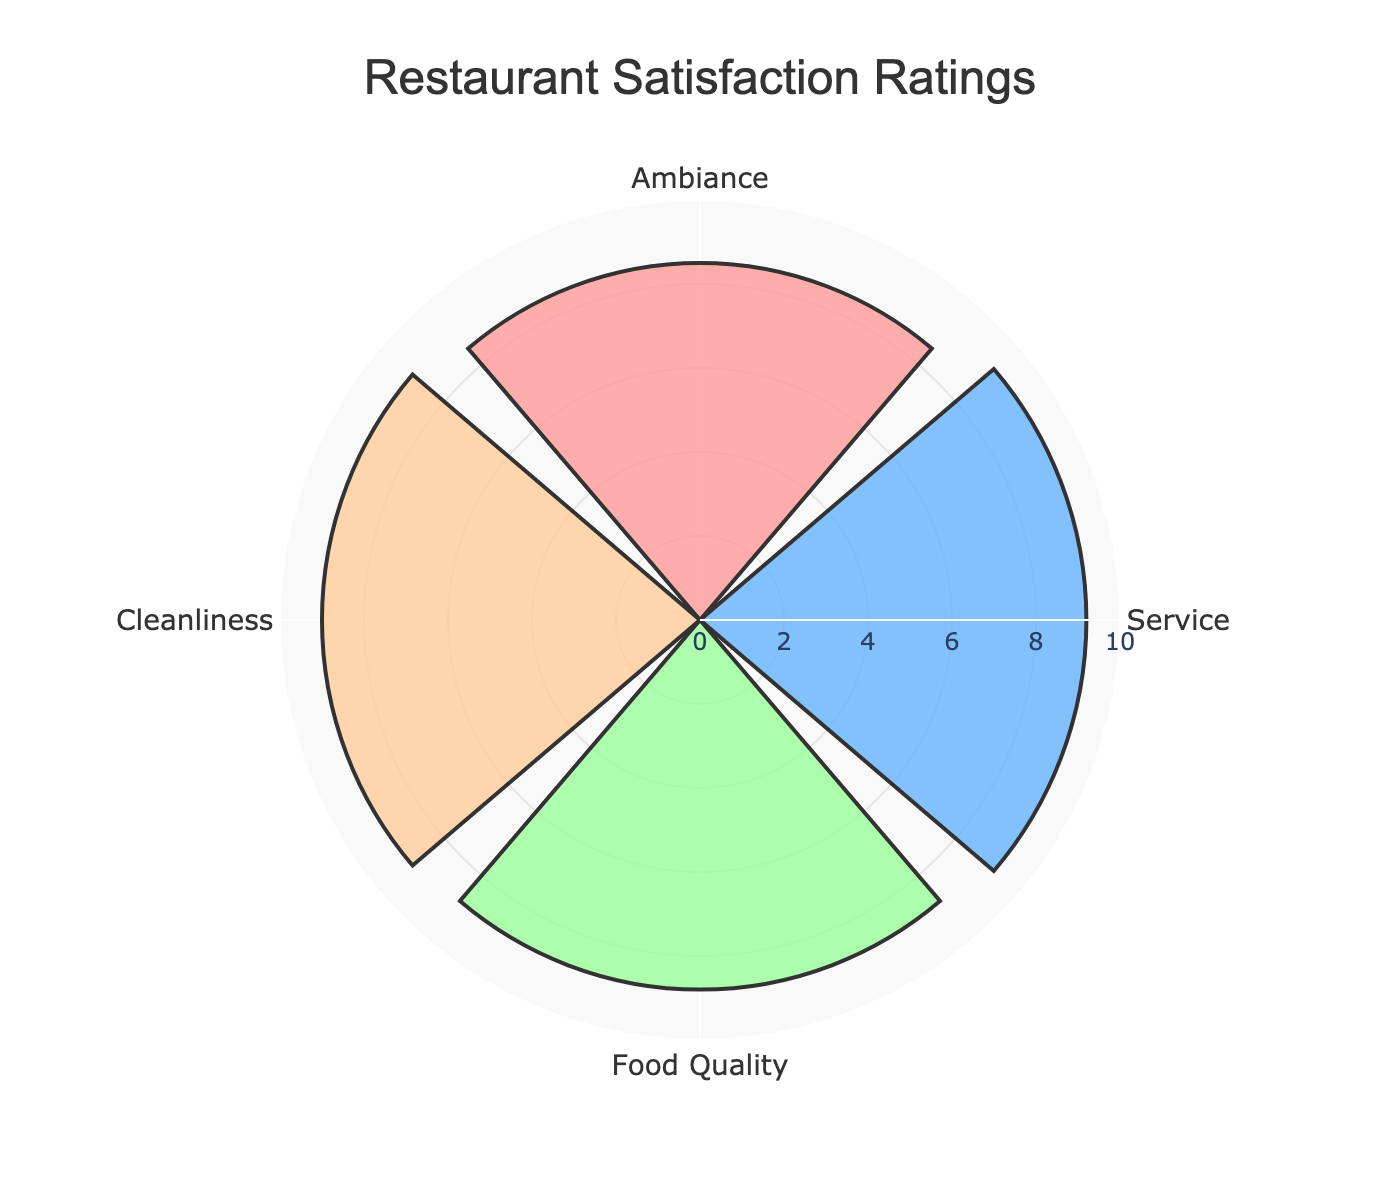what is the title of the figure? The title of the figure is typically found at the top and is often the largest text in the plot. It provides a summary of what the chart is about. In this case, the data and code specify that the title is "Restaurant Satisfaction Ratings".
Answer: Restaurant Satisfaction Ratings how many service aspects are shown on the chart? By looking at the axis labels or segments in the chart, you can count the unique aspects. Here, there are four aspects: Ambiance, Service, Food Quality, and Cleanliness.
Answer: Four which service aspect received the highest rating? Identify the segment with the highest radial extension. According to the data, Service received the highest rating at 9.2.
Answer: Service compare the ratings for "Ambiance" and "Food Quality". Which one is higher and by how much? Find the ratings for both aspects in the chart. Ambiance is rated 8.5, and Food Quality is 8.8. The difference is found by subtracting 8.5 from 8.8.
Answer: Food Quality is higher by 0.3 what is the average rating of all service aspects? Add all the ratings together (8.5 + 9.2 + 8.8 + 9.0) and then divide by the number of aspects (4) to find the average.
Answer: 8.875 which two service aspects received the same rating or closest ratings? Compare the numerical values for all aspects. Cleanliness received a rating of 9.0 and Food Quality received 8.8, making these the closest ratings.
Answer: Cleanliness and Food Quality which service aspect has the smallest rating, and what could be inferred about it? The smallest rating can be identified by finding the shortest segment. Here, Ambiance is the lowest at 8.5. This could suggest that while still good, Ambiance might need some improvement compared to other aspects.
Answer: Ambiance if the rating for "Cleanliness" was increased to 9.5, how would this affect the average rating? First, update Cleanliness' rating to 9.5. Sum the new ratings (8.5 + 9.2 + 8.8 + 9.5) and divide by 4. The new sum is 36, and the new average is 36/4.
Answer: 9.0 